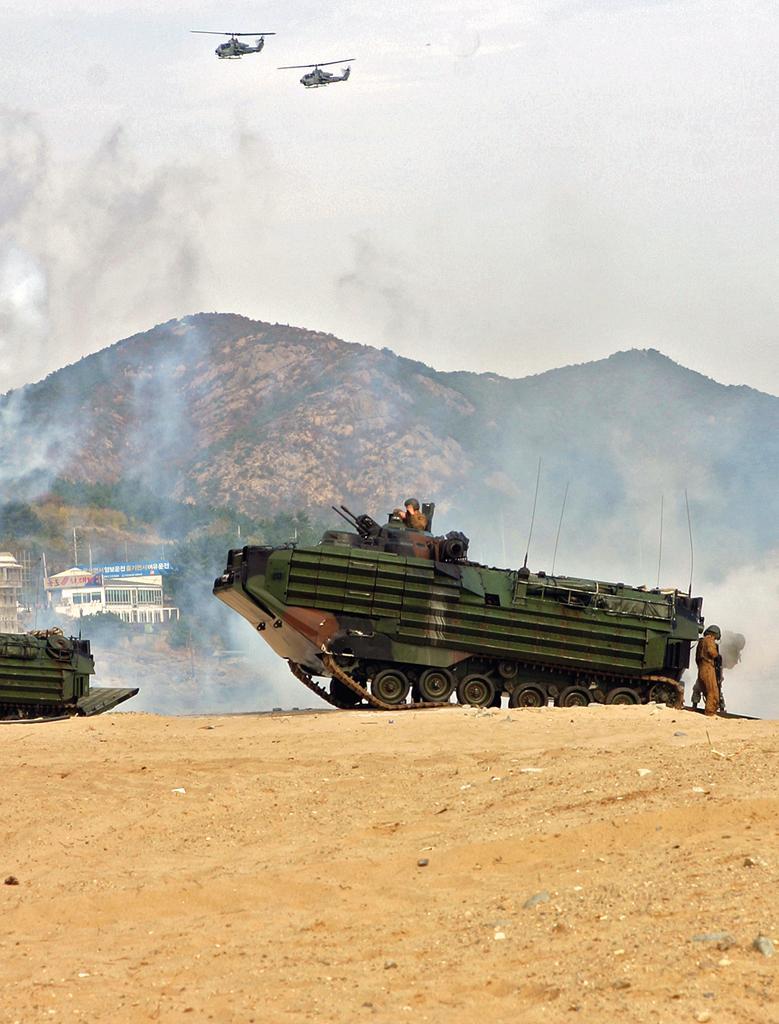Describe this image in one or two sentences. In this picture there is a man who is standing inside the tank. Beside the tank there is another man who is wearing army uniform. In background I can see the mountains, trees, buildings and poles. At the top I can see the two helicopters were flying. In the top right I can see the sky and clouds. Behind this tank I can see the smoke. 